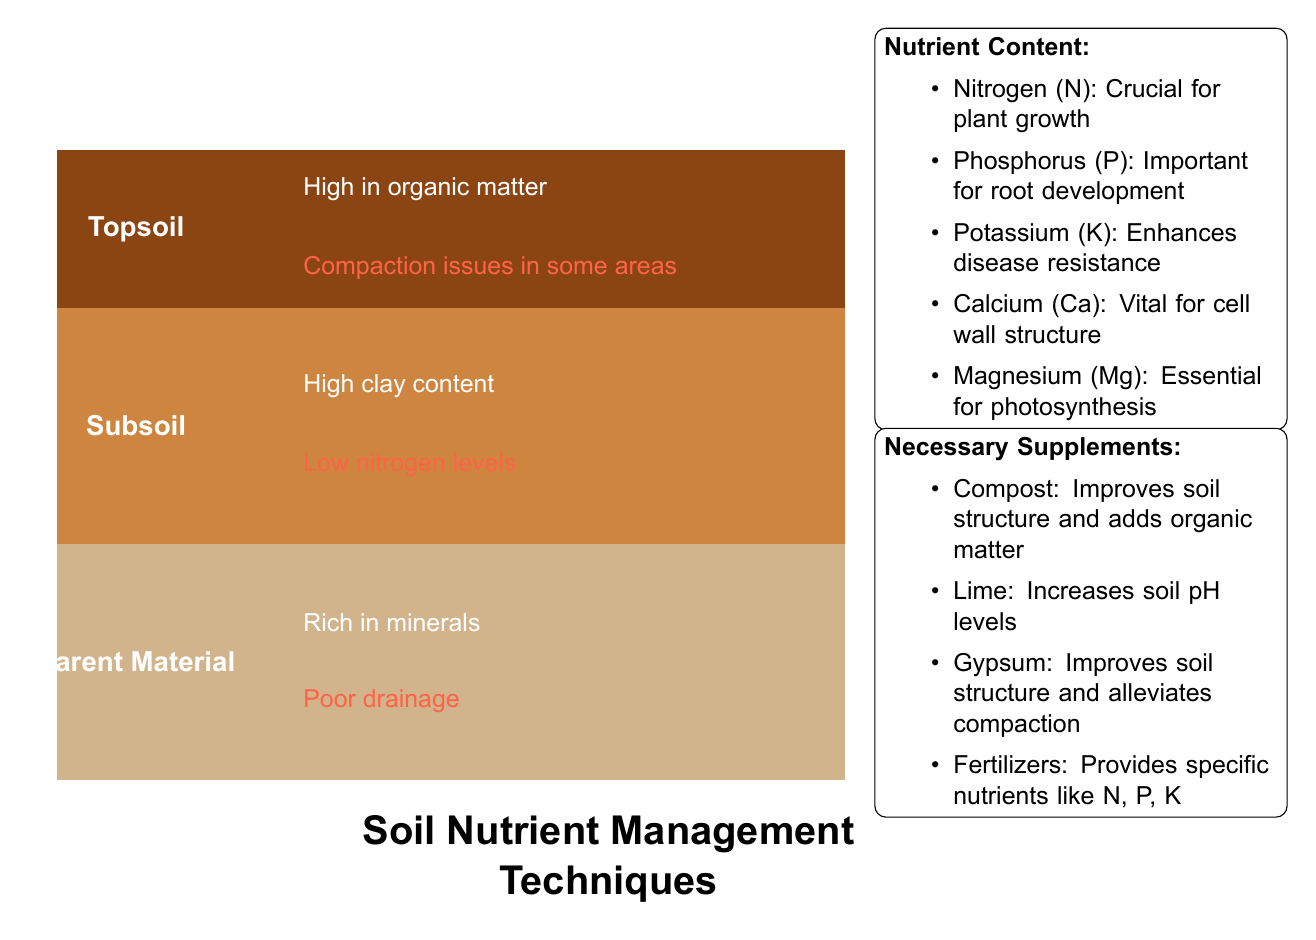What are the three soil layers shown in the diagram? The diagram clearly labels three different soil layers: Topsoil, Subsoil, and Parent Material. Each layer is visually distinct, allowing for easy identification.
Answer: Topsoil, Subsoil, Parent Material What is the primary content characteristic of the Topsoil layer? The Topsoil layer is noted for being high in organic matter, which is a critical factor in soil health. This information is explicitly stated in the diagram.
Answer: High in organic matter What compaction issue is noted for the Subsoil layer? The diagram highlights a compaction issue in some areas of the Subsoil. This specific detail points to potential problems that could affect soil management practices.
Answer: Compaction issues in some areas Which nutrient is crucial for plant growth according to the nutrient content section? The nutrient content section specifies that Nitrogen (N) is crucial for plant growth. This is a straightforward answer as it is clearly presented in the diagram.
Answer: Nitrogen (N) What supplement is recommended to improve soil structure? The diagram lists several necessary supplements, among which compost is specifically noted for improving soil structure and adding organic matter.
Answer: Compost Explain the reason for recommending lime as a supplement. Lime is noted in the diagram for its ability to increase soil pH levels. This implies that it's used to address acidity issues in soil, promoting better nutrient availability for plants.
Answer: Increases soil pH levels What nutrient is important for root development? The diagram mentions that Phosphorus (P) is important for root development. This piece of information is clearly outlined in the nutrient content section.
Answer: Phosphorus (P) Identify one problem area associated with the Parent Material. According to the diagram, one problem associated with the Parent Material is poor drainage. This detail emphasizes a challenge that may arise in soil management.
Answer: Poor drainage 